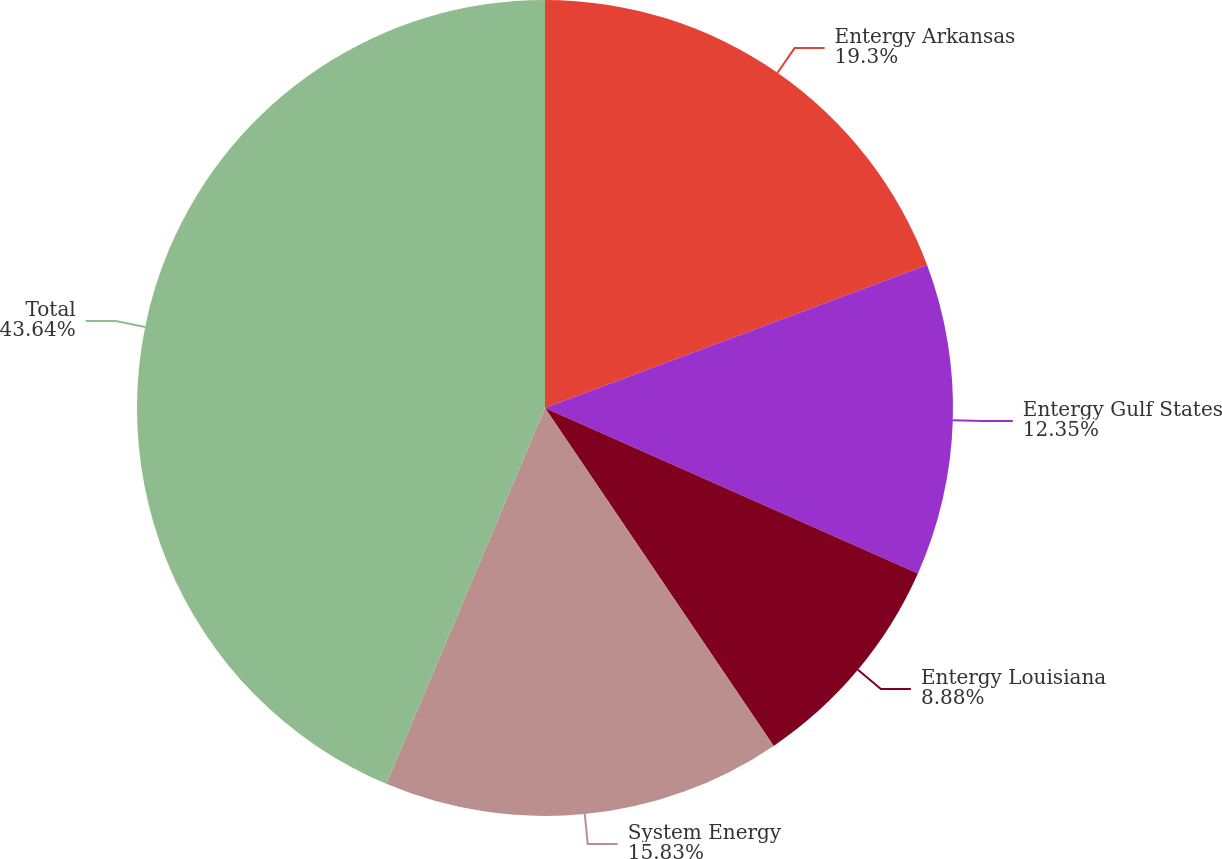Convert chart. <chart><loc_0><loc_0><loc_500><loc_500><pie_chart><fcel>Entergy Arkansas<fcel>Entergy Gulf States<fcel>Entergy Louisiana<fcel>System Energy<fcel>Total<nl><fcel>19.3%<fcel>12.35%<fcel>8.88%<fcel>15.83%<fcel>43.64%<nl></chart> 